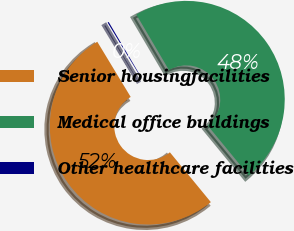<chart> <loc_0><loc_0><loc_500><loc_500><pie_chart><fcel>Senior housingfacilities<fcel>Medical office buildings<fcel>Other healthcare facilities<nl><fcel>52.29%<fcel>47.51%<fcel>0.2%<nl></chart> 